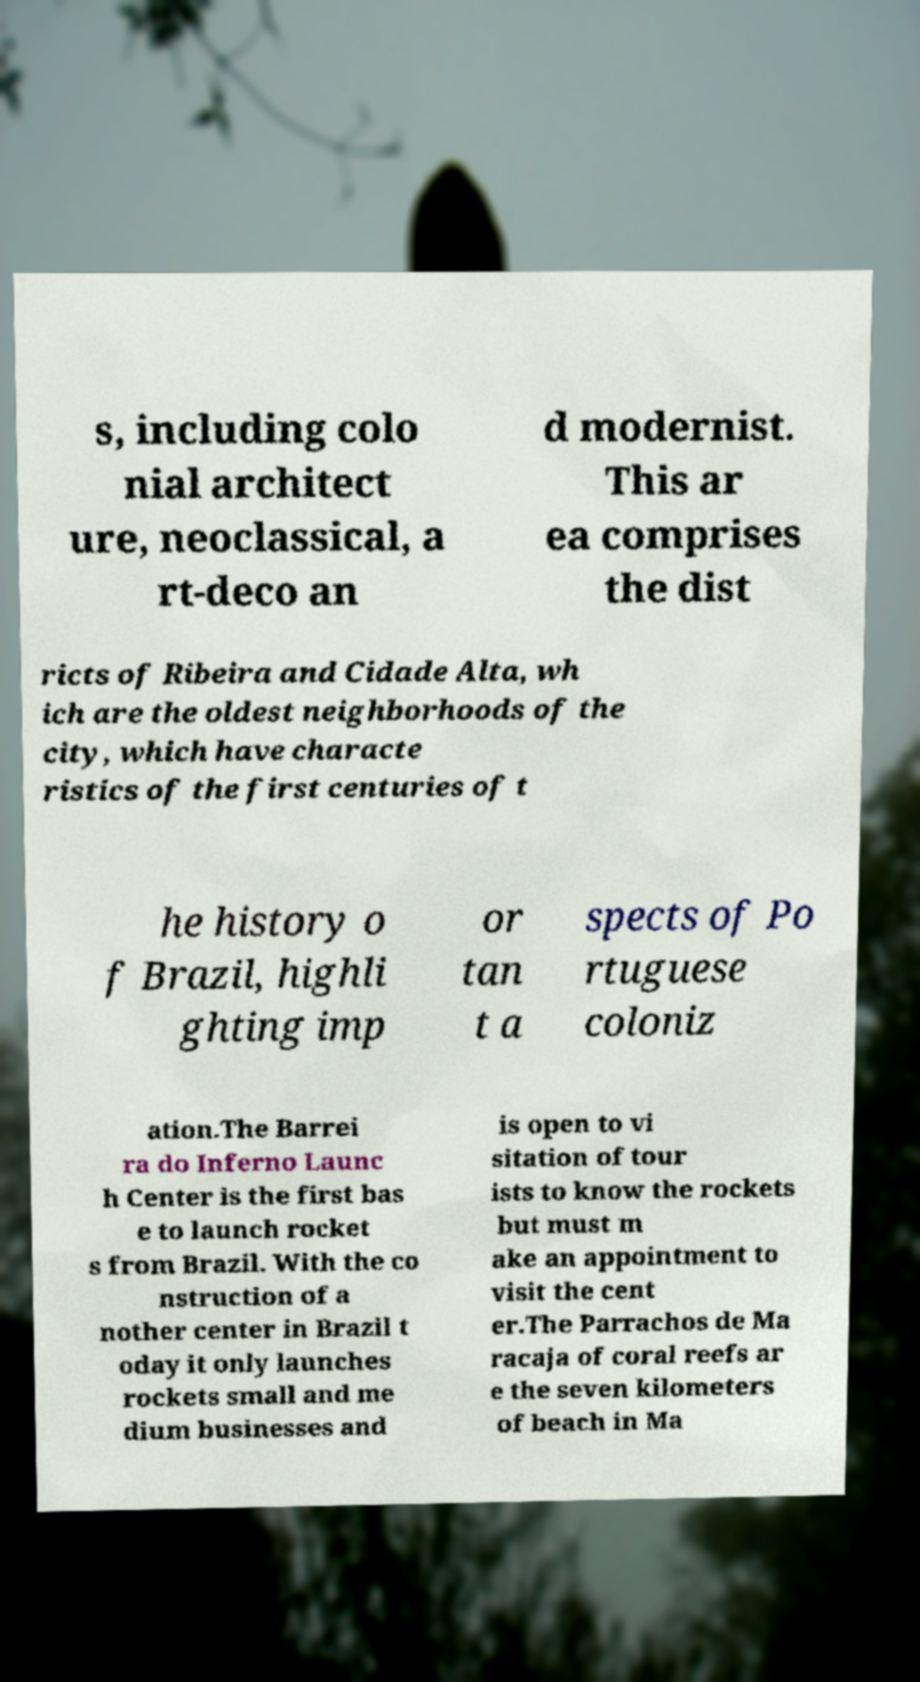What messages or text are displayed in this image? I need them in a readable, typed format. s, including colo nial architect ure, neoclassical, a rt-deco an d modernist. This ar ea comprises the dist ricts of Ribeira and Cidade Alta, wh ich are the oldest neighborhoods of the city, which have characte ristics of the first centuries of t he history o f Brazil, highli ghting imp or tan t a spects of Po rtuguese coloniz ation.The Barrei ra do Inferno Launc h Center is the first bas e to launch rocket s from Brazil. With the co nstruction of a nother center in Brazil t oday it only launches rockets small and me dium businesses and is open to vi sitation of tour ists to know the rockets but must m ake an appointment to visit the cent er.The Parrachos de Ma racaja of coral reefs ar e the seven kilometers of beach in Ma 